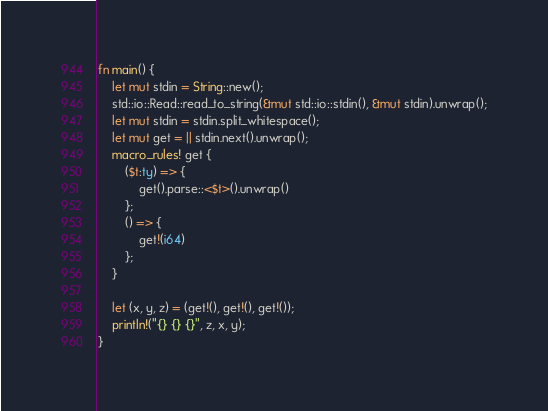<code> <loc_0><loc_0><loc_500><loc_500><_Rust_>fn main() {
    let mut stdin = String::new();
    std::io::Read::read_to_string(&mut std::io::stdin(), &mut stdin).unwrap();
    let mut stdin = stdin.split_whitespace();
    let mut get = || stdin.next().unwrap();
    macro_rules! get {
        ($t:ty) => {
            get().parse::<$t>().unwrap()
        };
        () => {
            get!(i64)
        };
    }

    let (x, y, z) = (get!(), get!(), get!());
    println!("{} {} {}", z, x, y);
}
</code> 